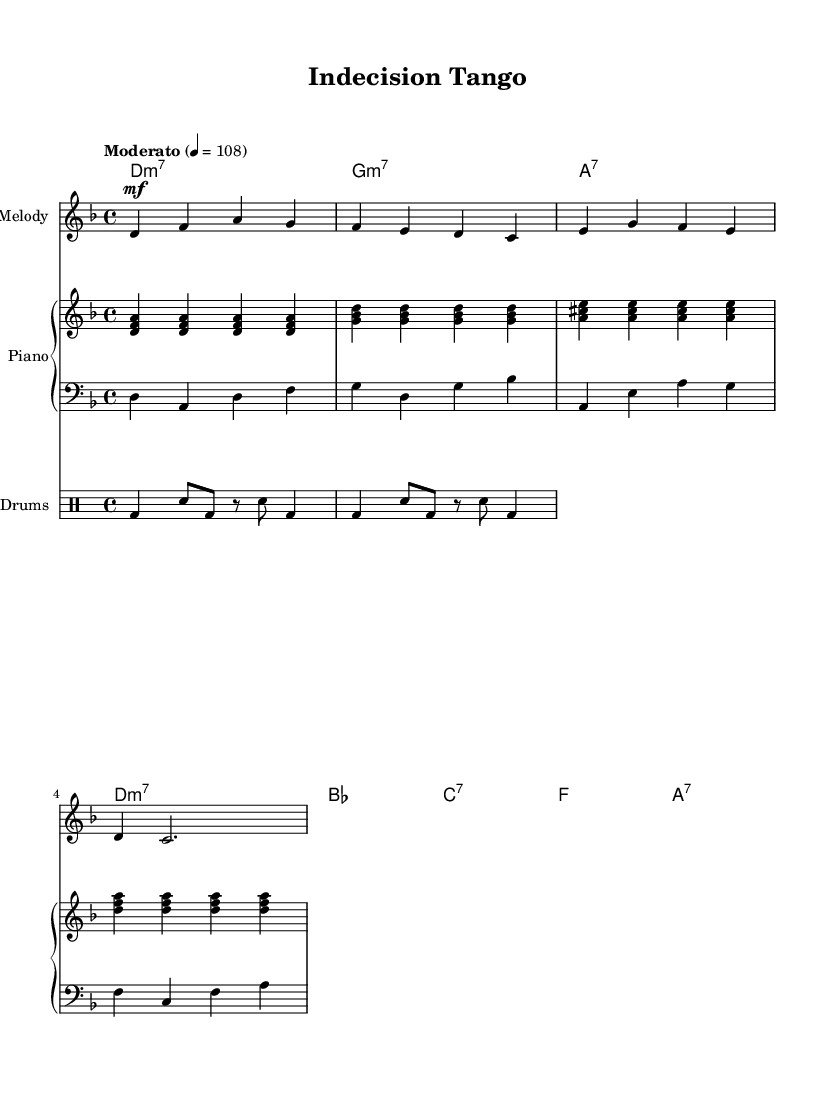What is the key signature of this music? The key signature is D minor, which has one flat (B flat). This can be identified by looking at the key signature at the beginning of the staff.
Answer: D minor What is the time signature of this music? The time signature is 4/4, indicated at the beginning of the score. This means there are four beats in each measure, and the quarter note gets one beat.
Answer: 4/4 What is the tempo marking for this piece? The tempo marking is "Moderato," which suggests a moderately paced performance. This is indicated in the tempo section at the top of the score.
Answer: Moderato Identify the chord progression used in the first four measures. The chord progression in the first four measures is D minor 7, G minor 7, A 7, and D minor 7. This can be deduced by looking at the chord names written above the staff for the melody and analyzing them measure by measure.
Answer: D minor 7, G minor 7, A 7, D minor 7 What style of music does this piece represent? This piece represents Latin jazz fusion, indicated by the rhythmic elements and harmonies that blend Latin rhythms with jazz influences. The title "Indecision Tango" and the employed musical elements also reflect this fusion style.
Answer: Latin jazz fusion How many beats are there in the first measure? In the first measure, there are four beats, as indicated by the 4/4 time signature. Each quarter note receives one beat, and the notes combine to make a total of four beats.
Answer: 4 beats 